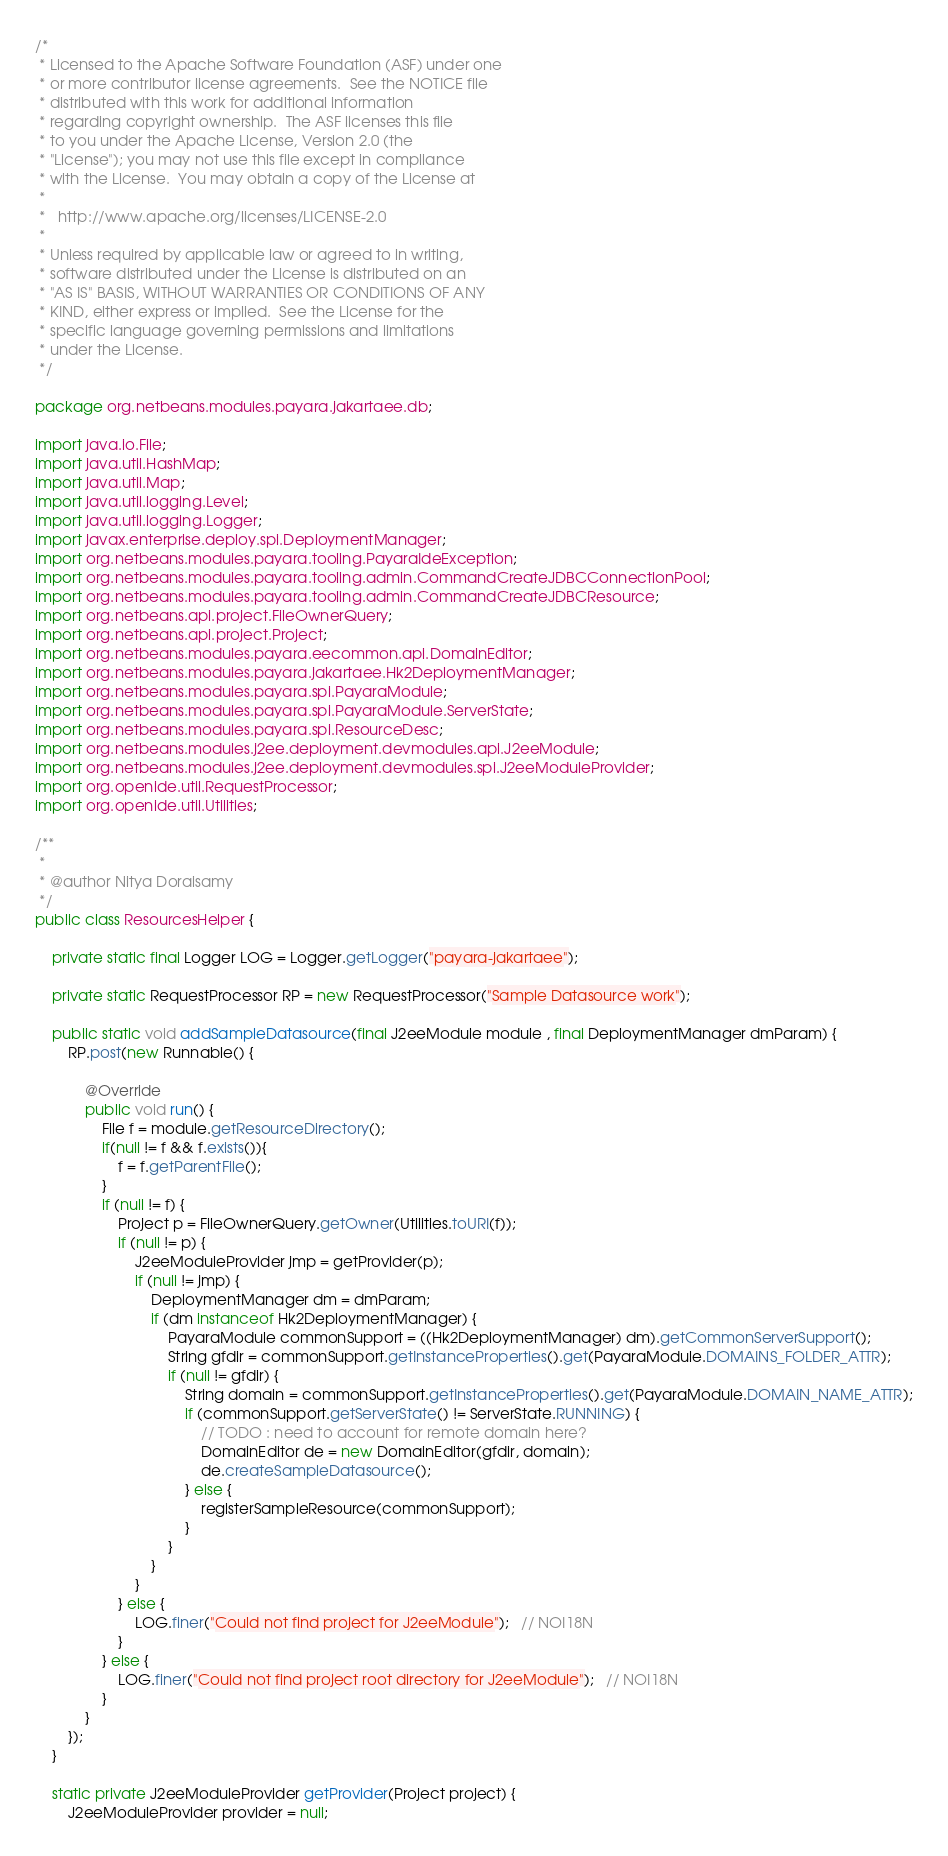Convert code to text. <code><loc_0><loc_0><loc_500><loc_500><_Java_>/*
 * Licensed to the Apache Software Foundation (ASF) under one
 * or more contributor license agreements.  See the NOTICE file
 * distributed with this work for additional information
 * regarding copyright ownership.  The ASF licenses this file
 * to you under the Apache License, Version 2.0 (the
 * "License"); you may not use this file except in compliance
 * with the License.  You may obtain a copy of the License at
 *
 *   http://www.apache.org/licenses/LICENSE-2.0
 *
 * Unless required by applicable law or agreed to in writing,
 * software distributed under the License is distributed on an
 * "AS IS" BASIS, WITHOUT WARRANTIES OR CONDITIONS OF ANY
 * KIND, either express or implied.  See the License for the
 * specific language governing permissions and limitations
 * under the License.
 */

package org.netbeans.modules.payara.jakartaee.db;

import java.io.File;
import java.util.HashMap;
import java.util.Map;
import java.util.logging.Level;
import java.util.logging.Logger;
import javax.enterprise.deploy.spi.DeploymentManager;
import org.netbeans.modules.payara.tooling.PayaraIdeException;
import org.netbeans.modules.payara.tooling.admin.CommandCreateJDBCConnectionPool;
import org.netbeans.modules.payara.tooling.admin.CommandCreateJDBCResource;
import org.netbeans.api.project.FileOwnerQuery;
import org.netbeans.api.project.Project;
import org.netbeans.modules.payara.eecommon.api.DomainEditor;
import org.netbeans.modules.payara.jakartaee.Hk2DeploymentManager;
import org.netbeans.modules.payara.spi.PayaraModule;
import org.netbeans.modules.payara.spi.PayaraModule.ServerState;
import org.netbeans.modules.payara.spi.ResourceDesc;
import org.netbeans.modules.j2ee.deployment.devmodules.api.J2eeModule;
import org.netbeans.modules.j2ee.deployment.devmodules.spi.J2eeModuleProvider;
import org.openide.util.RequestProcessor;
import org.openide.util.Utilities;

/**
 *
 * @author Nitya Doraisamy
 */
public class ResourcesHelper {

    private static final Logger LOG = Logger.getLogger("payara-jakartaee");

    private static RequestProcessor RP = new RequestProcessor("Sample Datasource work");

    public static void addSampleDatasource(final J2eeModule module , final DeploymentManager dmParam) {
        RP.post(new Runnable() {

            @Override
            public void run() {
                File f = module.getResourceDirectory();
                if(null != f && f.exists()){
                    f = f.getParentFile();
                }
                if (null != f) {
                    Project p = FileOwnerQuery.getOwner(Utilities.toURI(f));
                    if (null != p) {
                        J2eeModuleProvider jmp = getProvider(p);
                        if (null != jmp) {
                            DeploymentManager dm = dmParam;
                            if (dm instanceof Hk2DeploymentManager) {
                                PayaraModule commonSupport = ((Hk2DeploymentManager) dm).getCommonServerSupport();
                                String gfdir = commonSupport.getInstanceProperties().get(PayaraModule.DOMAINS_FOLDER_ATTR);
                                if (null != gfdir) {
                                    String domain = commonSupport.getInstanceProperties().get(PayaraModule.DOMAIN_NAME_ATTR);
                                    if (commonSupport.getServerState() != ServerState.RUNNING) {
                                        // TODO : need to account for remote domain here?
                                        DomainEditor de = new DomainEditor(gfdir, domain);
                                        de.createSampleDatasource();
                                    } else {
                                        registerSampleResource(commonSupport);
                                    }
                                }
                            }
                        }
                    } else {
                        LOG.finer("Could not find project for J2eeModule");   // NOI18N
                    }
                } else {
                    LOG.finer("Could not find project root directory for J2eeModule");   // NOI18N
                }
            }
        });
    }

    static private J2eeModuleProvider getProvider(Project project) {
        J2eeModuleProvider provider = null;</code> 